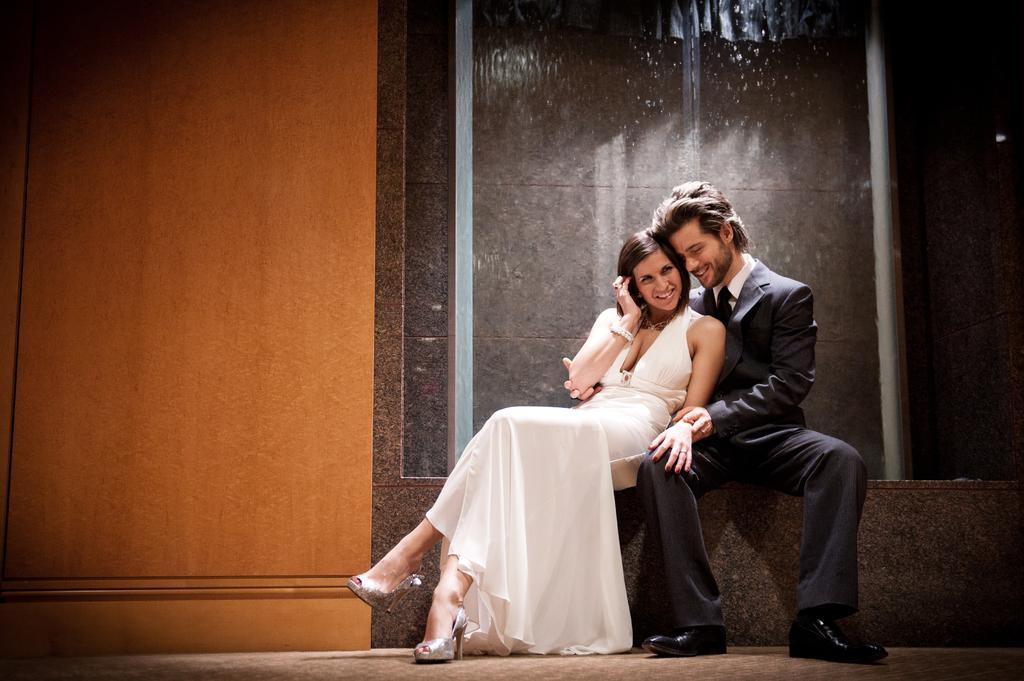Describe this image in one or two sentences. These two people are sitting and smiling. This woman wore white dress and this man wore a black suit. Background there is a wall. 